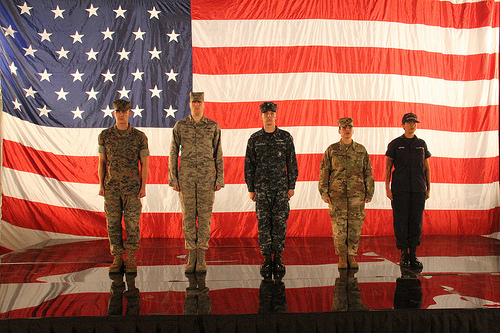<image>
Is the reflection under the flag? Yes. The reflection is positioned underneath the flag, with the flag above it in the vertical space. Is the man behind the flag? No. The man is not behind the flag. From this viewpoint, the man appears to be positioned elsewhere in the scene. 